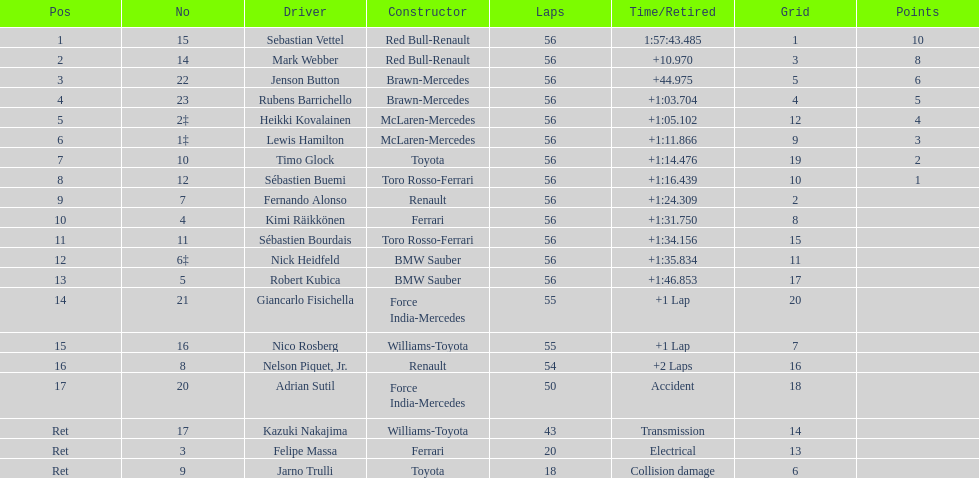What is the count of drivers who did not manage to complete 56 laps? 7. 